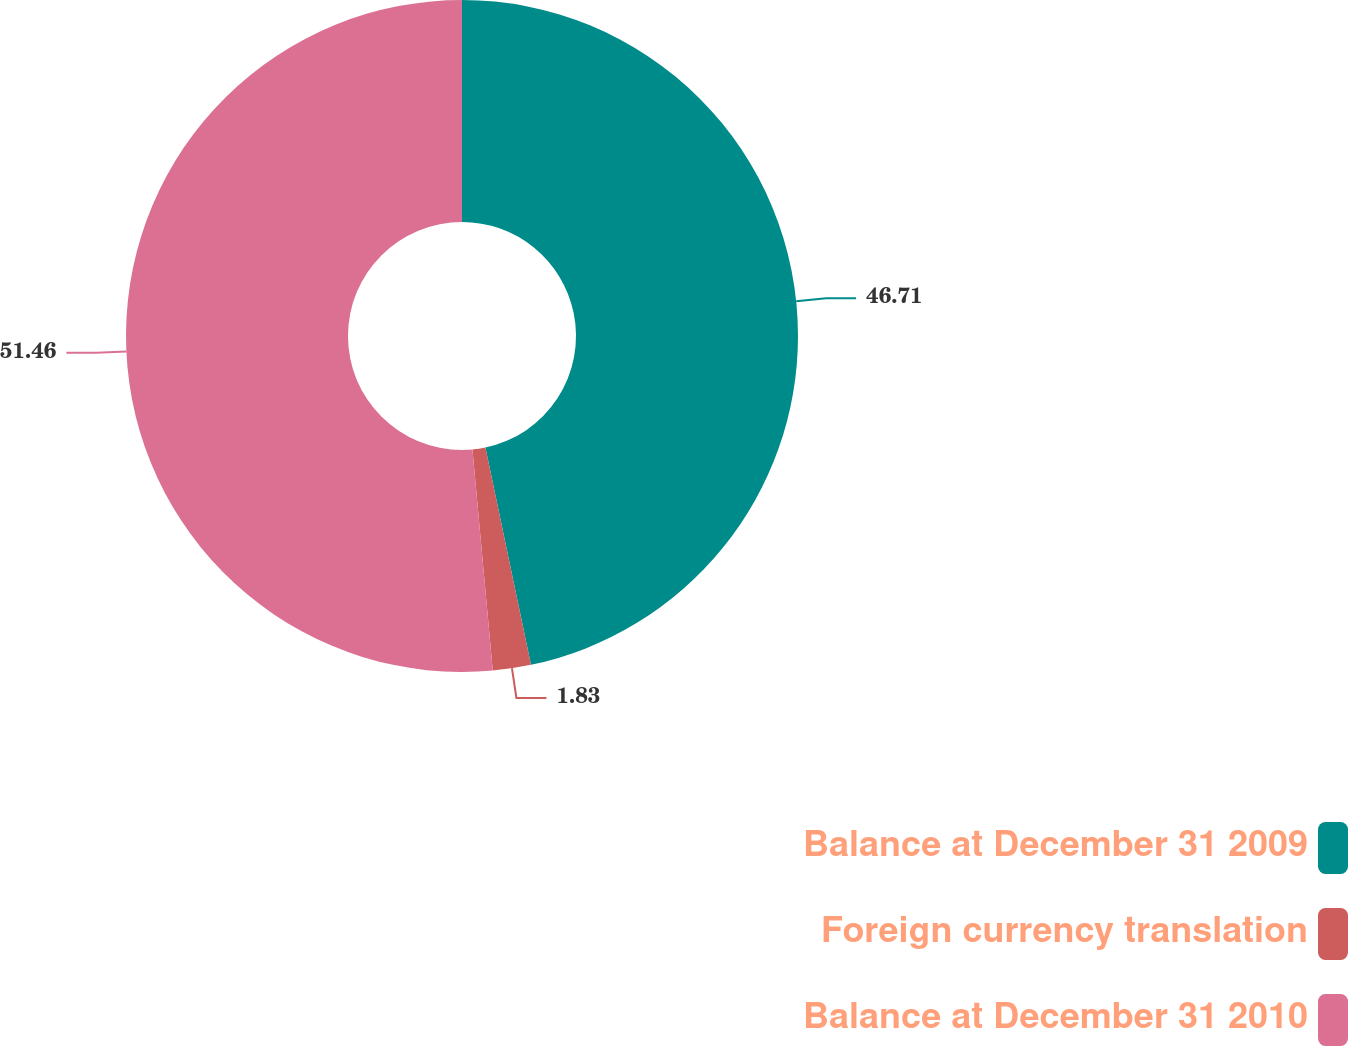Convert chart to OTSL. <chart><loc_0><loc_0><loc_500><loc_500><pie_chart><fcel>Balance at December 31 2009<fcel>Foreign currency translation<fcel>Balance at December 31 2010<nl><fcel>46.71%<fcel>1.83%<fcel>51.46%<nl></chart> 